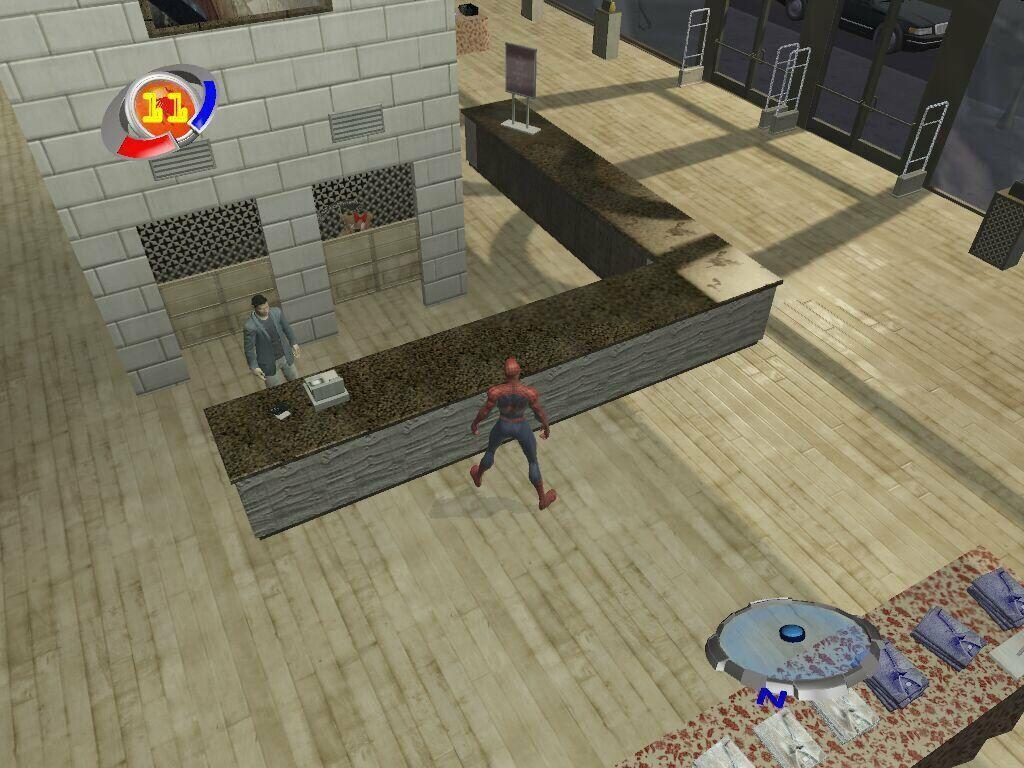Please provide a concise description of this image. In this image we can see the animated picture and in the picture, we can see the inner view of a building and there is a spider man standing in the middle of the image. We can see a person and there are some other objects in the building and in the top right side of the image we can see a vehicle on the road. 